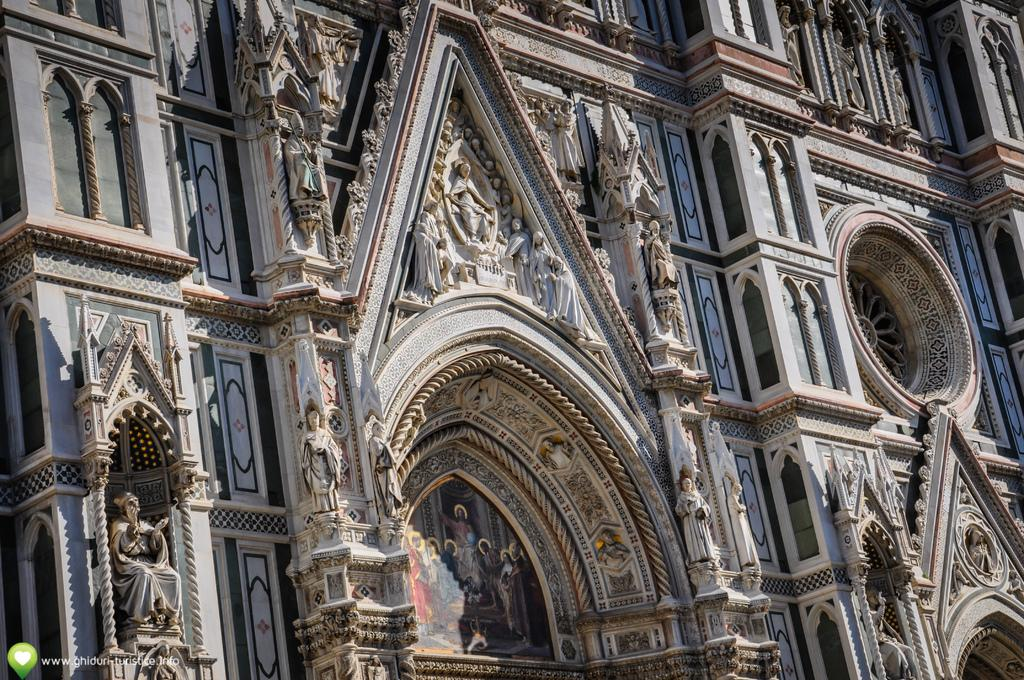What can be seen in the bottom left corner of the image? There is a watermark on the bottom left of the image. What is visible in the background of the image? There is a building in the background of the image. What features can be observed on the building? The building has windows and sculptures on its wall. How does the fog affect the visibility of the building in the image? There is no fog present in the image, so it does not affect the visibility of the building. 